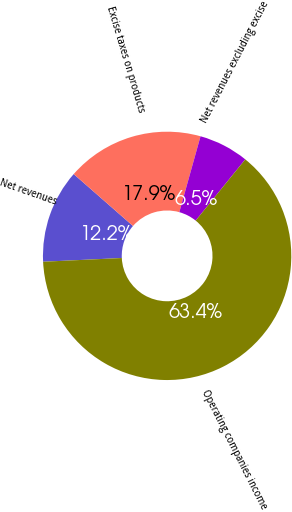Convert chart to OTSL. <chart><loc_0><loc_0><loc_500><loc_500><pie_chart><fcel>Net revenues<fcel>Excise taxes on products<fcel>Net revenues excluding excise<fcel>Operating companies income<nl><fcel>12.2%<fcel>17.89%<fcel>6.5%<fcel>63.41%<nl></chart> 